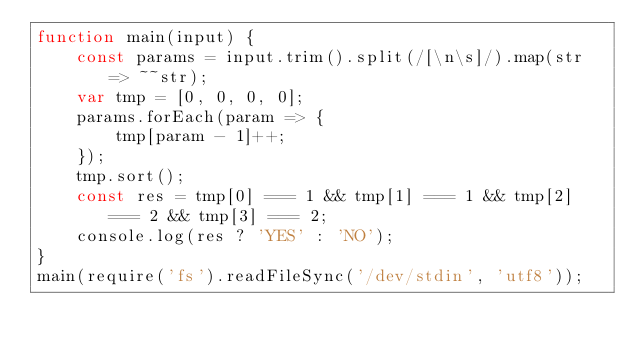<code> <loc_0><loc_0><loc_500><loc_500><_JavaScript_>function main(input) {
    const params = input.trim().split(/[\n\s]/).map(str => ~~str);
    var tmp = [0, 0, 0, 0];
    params.forEach(param => {
        tmp[param - 1]++;
    });
    tmp.sort();
    const res = tmp[0] === 1 && tmp[1] === 1 && tmp[2] === 2 && tmp[3] === 2;
    console.log(res ? 'YES' : 'NO');
}
main(require('fs').readFileSync('/dev/stdin', 'utf8'));</code> 